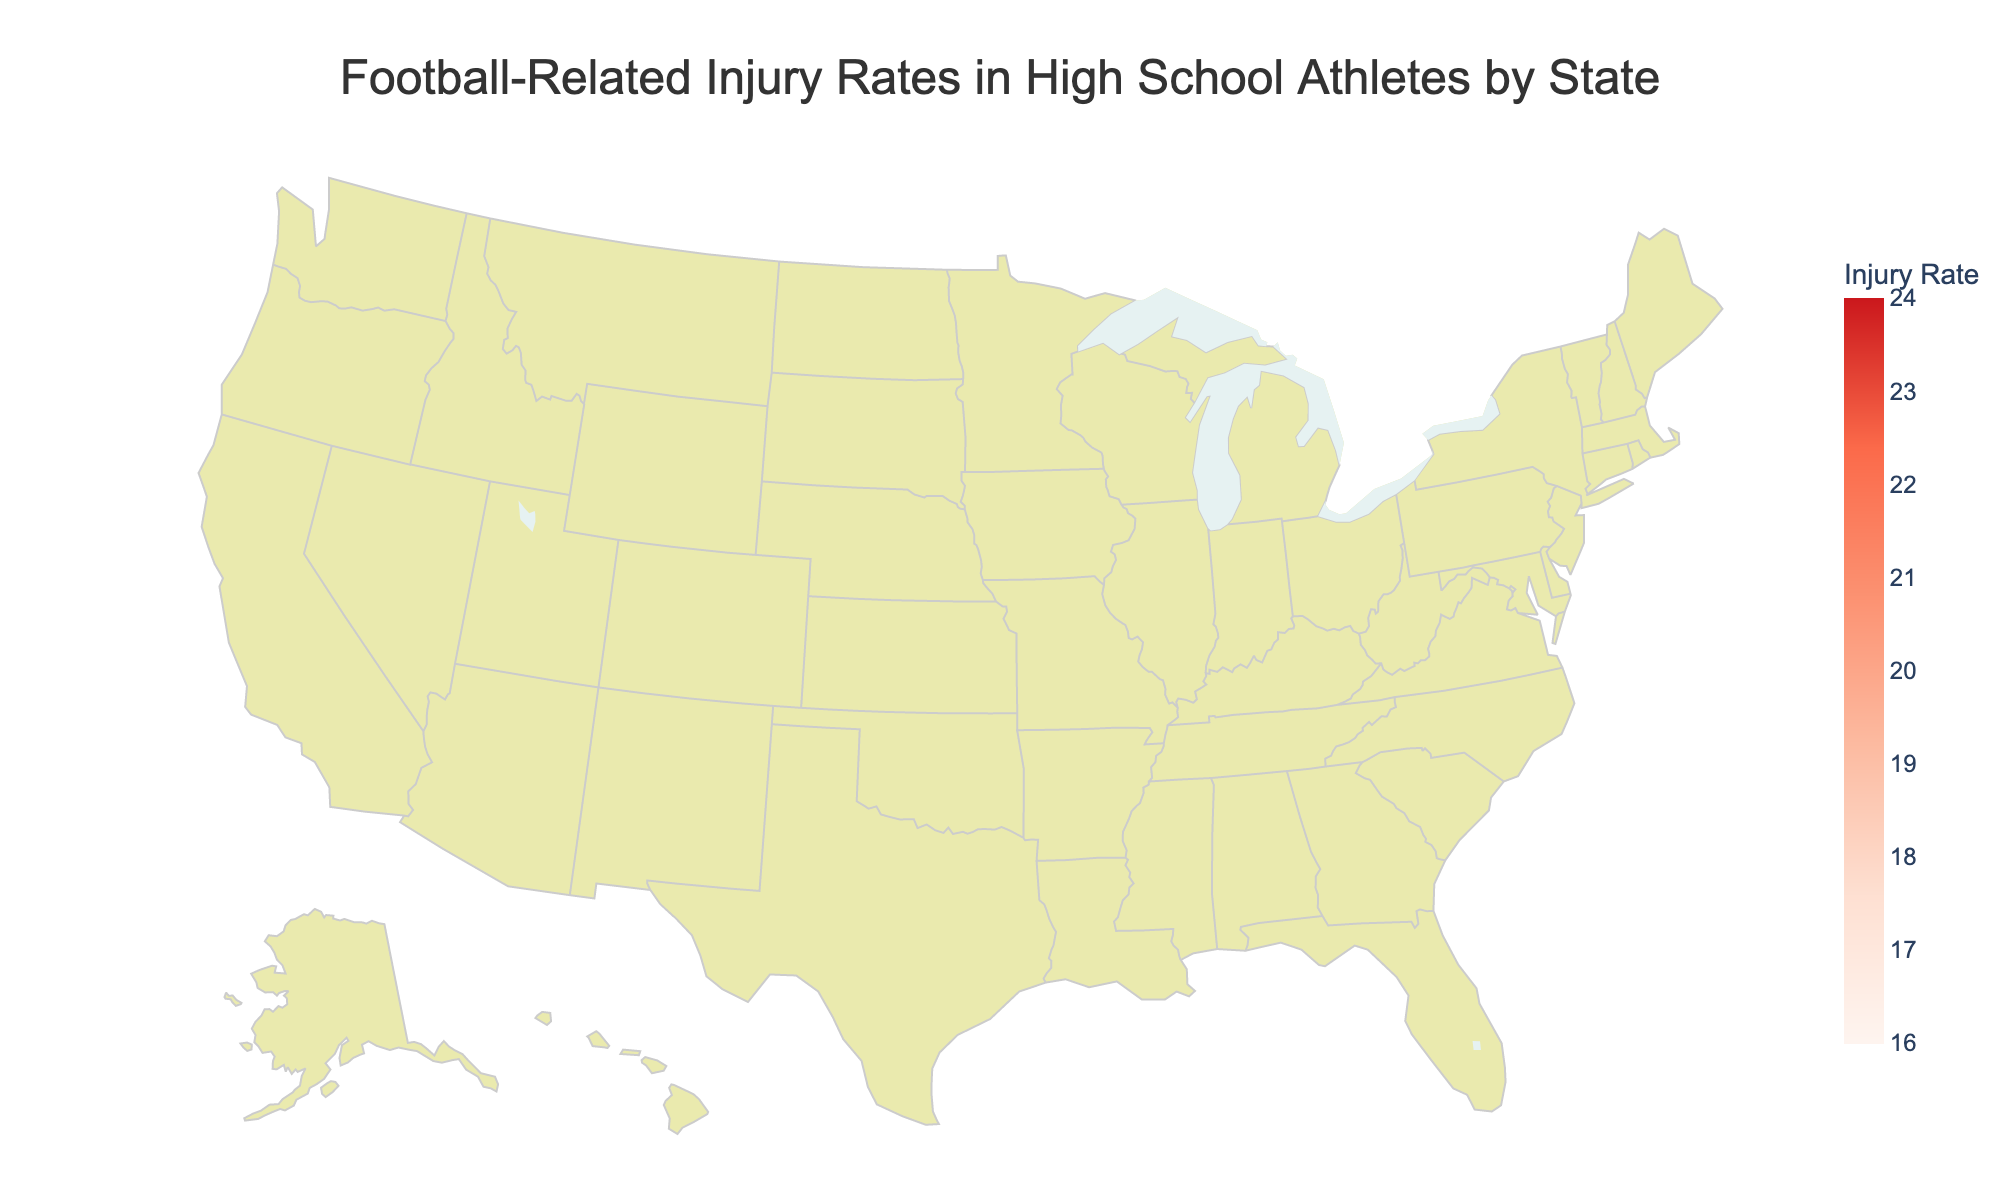Which state has the highest injury rate? Look at the map and identify the state with the darkest color indicating the highest injury rate.
Answer: Alabama Which region has the most states with injury rates above 20 per 1000 athletes? Tally the states within each region that have injury rates above 20. The Southeast (Florida, Georgia, and Virginia) and South (Texas, Tennessee, Alabama) have the most.
Answer: South What is the difference in injury rates between the state with the highest rate and the state with the lowest rate? Subtract the lowest injury rate (Massachusetts, 16.5) from the highest injury rate (Alabama, 23.2). 23.2 - 16.5 = 6.7.
Answer: 6.7 Which state in the Midwest region has the highest injury rate? Identify the Midwest states and compare their injury rates. Missouri has the highest at 20.3.
Answer: Missouri Compare the injury rates of Texas and California. Which state has a higher rate and by how much? Texas has an injury rate of 22.5, while California has 18.2. Subtract California's rate from Texas's rate: 22.5 - 18.2 = 4.3.
Answer: Texas by 4.3 Which Northeast state has the lowest injury rate? Compare the injury rates of the Northeast states: Pennsylvania, New Jersey, and Massachusetts. Massachusetts has the lowest rate at 16.5.
Answer: Massachusetts What is the average injury rate across all the states shown in the map? Sum up all the injury rates and divide by the number of states (19). The sum is 355.0, so the average is 355.0 / 19 ≈ 18.68.
Answer: 18.68 How does the injury rate of Florida compare to the average injury rate across all states? The average injury rate is 18.68. Florida's rate is 20.7, which is higher. Subtract the average from Florida's rate: 20.7 - 18.68 ≈ 2.02.
Answer: 2.02 higher Which region has the most states with injury rates below 18 per 1000 athletes? Identify states with rates below 18 and count the number of states in each region. The Northeast (New Jersey and Massachusetts) has the most.
Answer: Northeast What is the injury rate range in the Southeast region, and what does this tell us about the variability of injury rates in this region? Identify the Southeast states and calculate their rates: Florida (20.7), Georgia (21.3), Virginia (20.1). Subtract the lowest rate from the highest: 21.3 - 20.1 = 1.2. This narrow range indicates low variability.
Answer: 1.2, low variability 